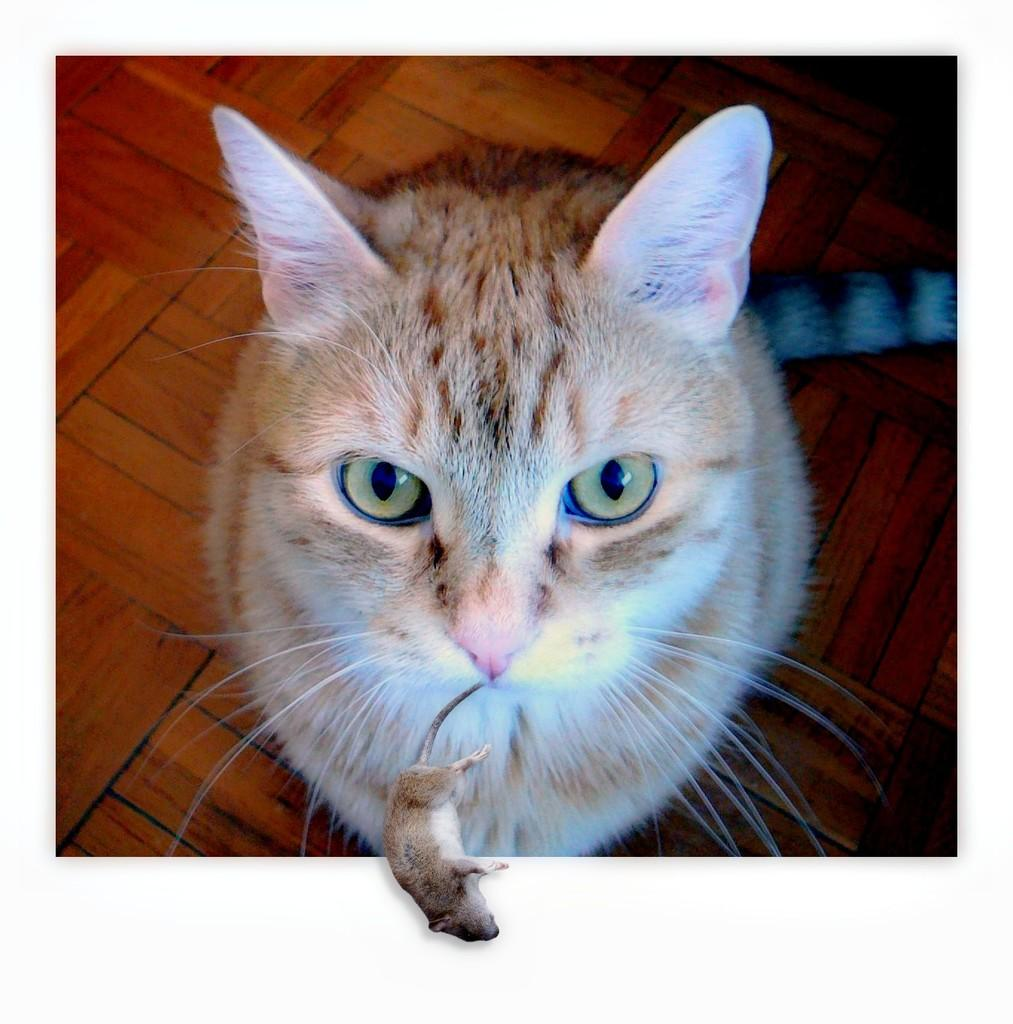What animal is the main subject of the image? There is a cat in the image. What is the cat doing in the image? The cat is biting a rat. Where is the nearest hospital to the cat in the image? There is no information about a hospital or its location in the image. 